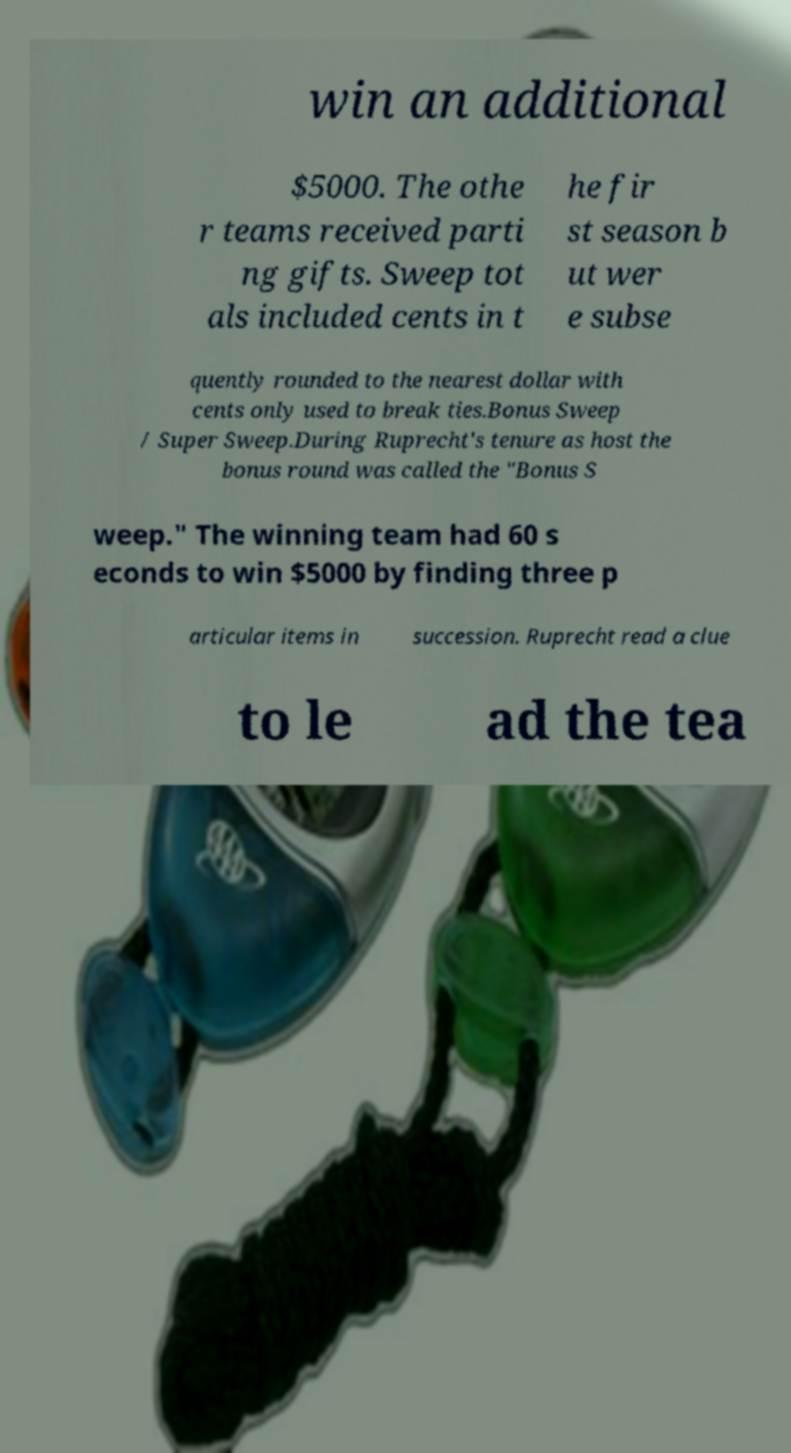Please read and relay the text visible in this image. What does it say? win an additional $5000. The othe r teams received parti ng gifts. Sweep tot als included cents in t he fir st season b ut wer e subse quently rounded to the nearest dollar with cents only used to break ties.Bonus Sweep / Super Sweep.During Ruprecht's tenure as host the bonus round was called the "Bonus S weep." The winning team had 60 s econds to win $5000 by finding three p articular items in succession. Ruprecht read a clue to le ad the tea 